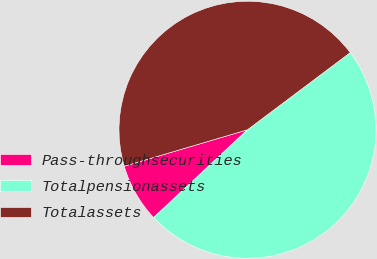Convert chart. <chart><loc_0><loc_0><loc_500><loc_500><pie_chart><fcel>Pass-throughsecurities<fcel>Totalpensionassets<fcel>Totalassets<nl><fcel>7.39%<fcel>48.29%<fcel>44.33%<nl></chart> 